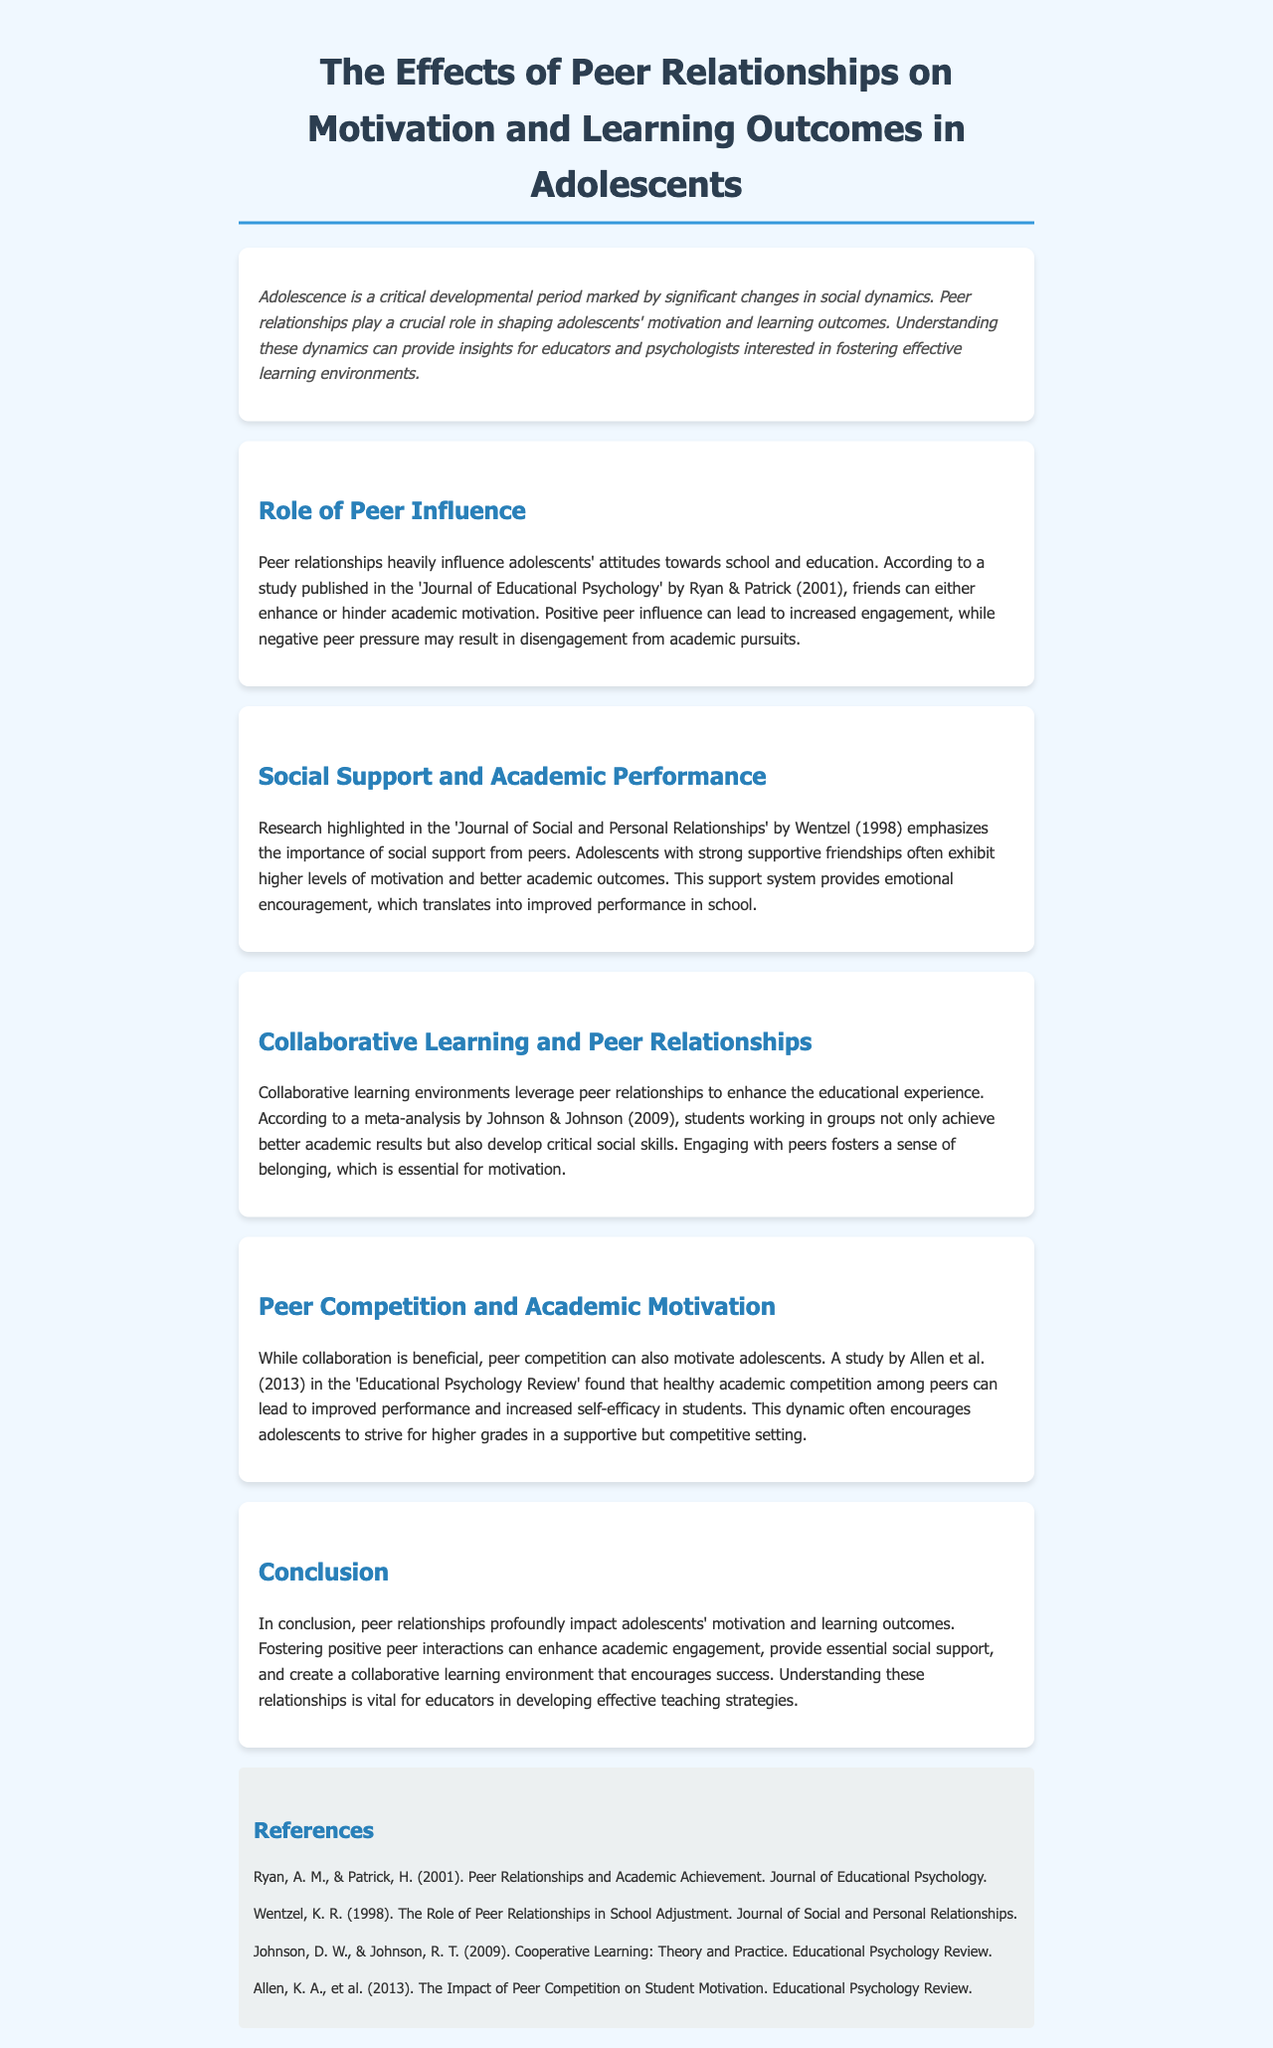What is the title of the document? The title is provided in the header section of the document.
Answer: The Effects of Peer Relationships on Motivation and Learning Outcomes in Adolescents Who conducted a study on peer relationships and academic achievement? The study is attributed to Ryan & Patrick in the 'Journal of Educational Psychology.'
Answer: Ryan & Patrick What year was the study by Wentzel published? The year is mentioned in the context of the research highlighted in the document.
Answer: 1998 What is one outcome of positive peer influence on adolescents? The document states that positive peer influence can lead to increased engagement.
Answer: Increased engagement What does collaborative learning enhance according to Johnson & Johnson? The content discusses the benefits outlined in the meta-analysis by Johnson & Johnson.
Answer: Academic results and critical social skills How does healthy competition among peers affect student motivation? The document specifies that it can lead to improved performance and increased self-efficacy.
Answer: Improved performance and increased self-efficacy Which journal did Allen et al. publish their findings in? The specific journal is mentioned in the context of the study discussed.
Answer: Educational Psychology Review What is the main conclusion about peer relationships? The conclusion summarizes the overall impact as discussed throughout the document.
Answer: Peer relationships profoundly impact adolescents' motivation and learning outcomes 